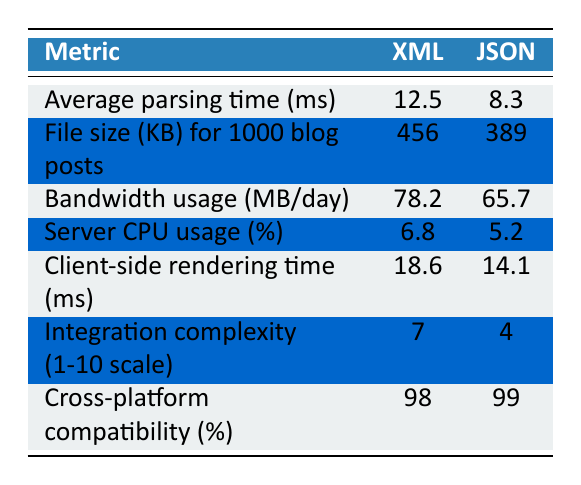What is the average parsing time for XML? The table shows that the average parsing time for XML is listed explicitly under the XML column for the corresponding metric. The value is 12.5 ms.
Answer: 12.5 ms Which format has a lower file size for 1000 blog posts? By comparing the values under the "File size (KB) for 1000 blog posts" metric in the table, we can see that JSON has a value of 389 KB, which is lower than the 456 KB for XML.
Answer: JSON Is the server CPU usage for XML greater than 5%? Looking at the server CPU usage metric, XML has a value of 6.8% which is indeed greater than 5%.
Answer: Yes What is the difference in bandwidth usage between XML and JSON? To find the difference, subtract the bandwidth usage of JSON (65.7 MB/day) from that of XML (78.2 MB/day): 78.2 - 65.7 = 12.5 MB/day.
Answer: 12.5 MB/day What is the average client-side rendering time for both formats? To get the average client-side rendering time, add the two values together: 18.6 ms (XML) + 14.1 ms (JSON) = 32.7 ms, then divide by 2: 32.7 / 2 = 16.35 ms.
Answer: 16.35 ms Which format has higher integration complexity on a scale of 1 to 10? By examining the integration complexity metric, XML scores 7 while JSON scores 4. Therefore, XML has higher integration complexity.
Answer: XML If the cross-platform compatibility of JSON is 99%, what is the percentage difference compared to XML? To find the percentage difference, subtract the cross-platform compatibility of XML (98%) from JSON (99%): 99 - 98 = 1%. Thus, there is a 1% difference.
Answer: 1% Which format requires more server CPU usage? From the table, XML has a server CPU usage of 6.8%, whereas JSON has a usage of 5.2%. Thus, XML requires more server CPU usage.
Answer: XML Is JSON more efficient in both bandwidth usage and file size for 1000 blog posts? Comparing both metrics, JSON has a lower bandwidth usage of 65.7 MB/day (compared to 78.2 MB for XML) and a smaller file size of 389 KB (compared to XML's 456 KB). Therefore, JSON is more efficient in both regards.
Answer: Yes 